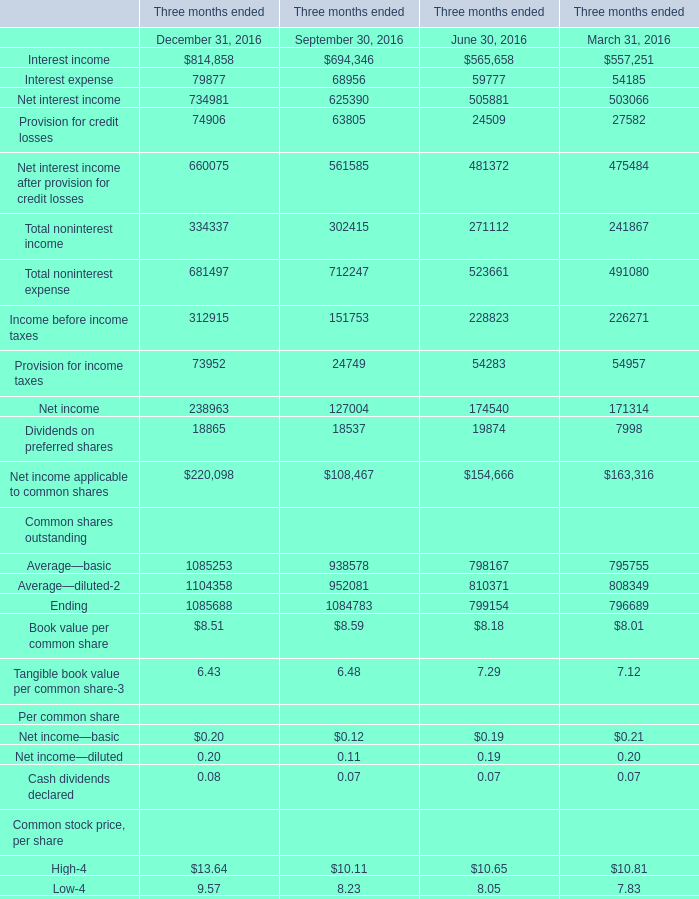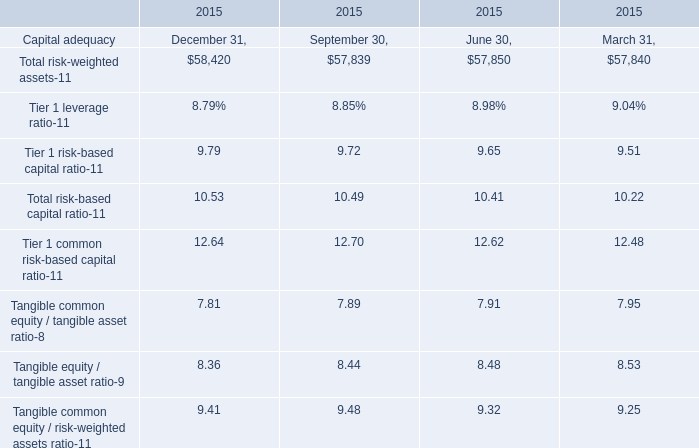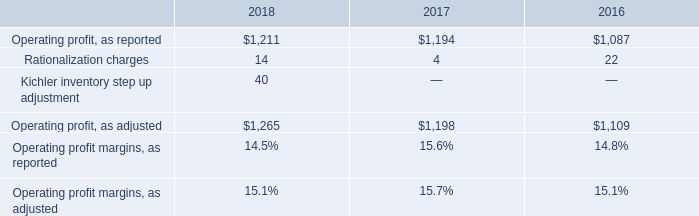In the section with the most Interest income, what is the growth rate of Interest expense 
Computations: ((79877 - 68956) / 68956)
Answer: 0.15838. 